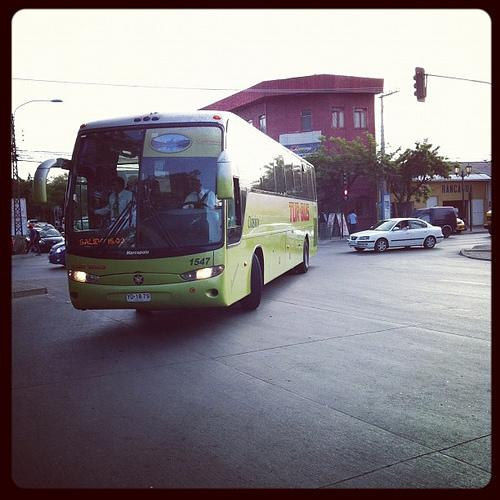Give a brief summary of the scenario depicted in the image. A green bus is turning on a road followed by a white car, with various passengers on board and pedestrians nearby, situated in an urban setting with traffic control elements and buildings. Count the total number of people in the image and describe their clothing and actions. There are 5 people: a man walking on the sidewalk, a man wearing a blue shirt, the bus driver in a white shirt, a man wearing a tie, and a person standing at the bus door. What emotions or sentiment can be interpreted from the image? The image portrays a typical busy urban scene with people commuting and vehicles on the move, depicting daily life and activity. Provide details about the traffic control and lighting elements in the image. There is a hanging traffic signal over the white car and a double light on a pole. A backside of a traffic light is also visible. The bus has an illuminated headlight and a front license plate. Describe the road surface and any markings in the image. The road is made of asphalt and has lines marking the lanes in the street. Identify the main colors found within the scene. The main colors in the scene are green, red, white, blue, and yellow. How many vehicles are present and what types are they? There are four vehicles: a green bus, a white car, a dark SUV, and an unspecified vehicle with side rear view mirror visible. What are the colors and primary features of the vehicles in the image, and what are they doing? There is a large pale green bus with red lettering, yellow headlights, and black tires turning on the road, followed by a small white four-door car with illuminated headlights. What color are the buildings and how many are there? There are three buildings: one red, one yellow, and one unspecified color. Identify the color and size of the buildings in the image, and their relation to the vehicles. The tallest red building is behind the green bus, and a small yellow building is in the scene as well. The red building appears near the person in blue shirt. 